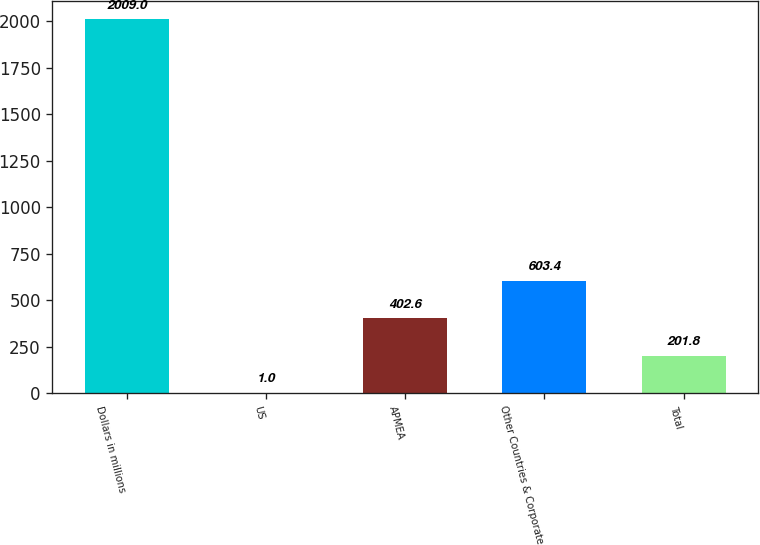Convert chart. <chart><loc_0><loc_0><loc_500><loc_500><bar_chart><fcel>Dollars in millions<fcel>US<fcel>APMEA<fcel>Other Countries & Corporate<fcel>Total<nl><fcel>2009<fcel>1<fcel>402.6<fcel>603.4<fcel>201.8<nl></chart> 